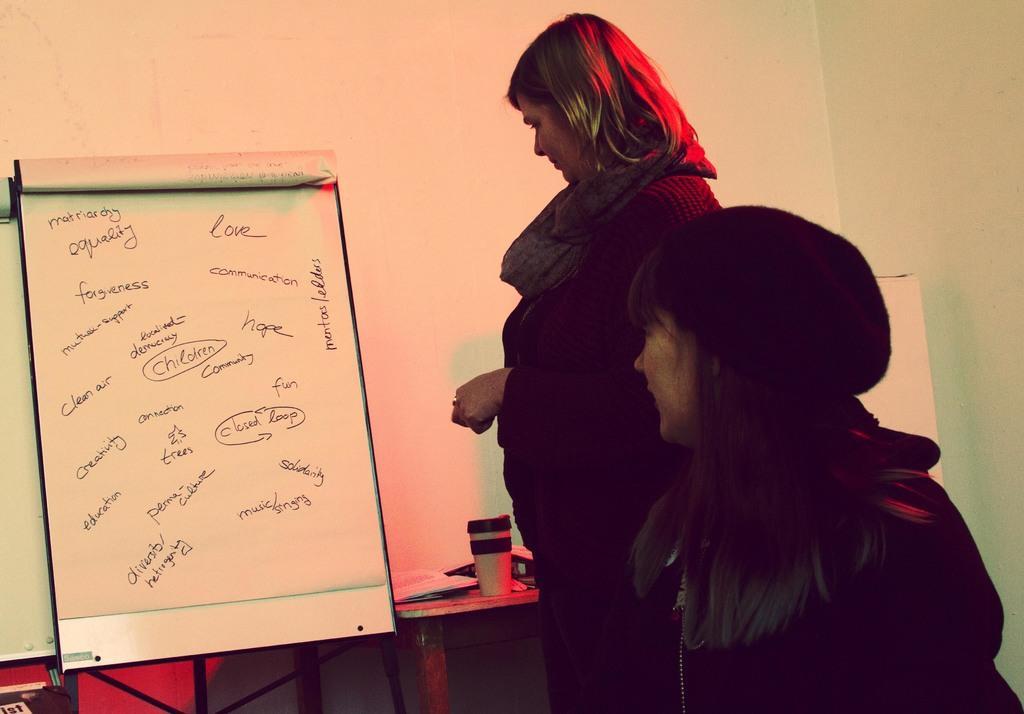Please provide a concise description of this image. In this picture I can see on the left side there is a paper board, in the middle a woman is standing and looking at that board. She wore black color coat and scarf, on the right side there is another woman she is also looking at that side, She wore black color cap and there is the wall in this image. 